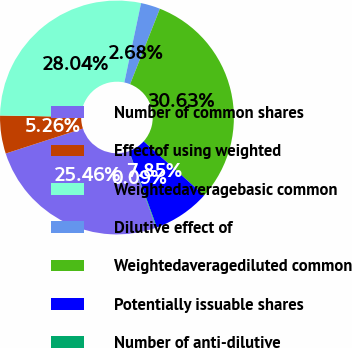Convert chart. <chart><loc_0><loc_0><loc_500><loc_500><pie_chart><fcel>Number of common shares<fcel>Effectof using weighted<fcel>Weightedaveragebasic common<fcel>Dilutive effect of<fcel>Weightedaveragediluted common<fcel>Potentially issuable shares<fcel>Number of anti-dilutive<nl><fcel>25.46%<fcel>5.26%<fcel>28.04%<fcel>2.68%<fcel>30.63%<fcel>7.85%<fcel>0.09%<nl></chart> 